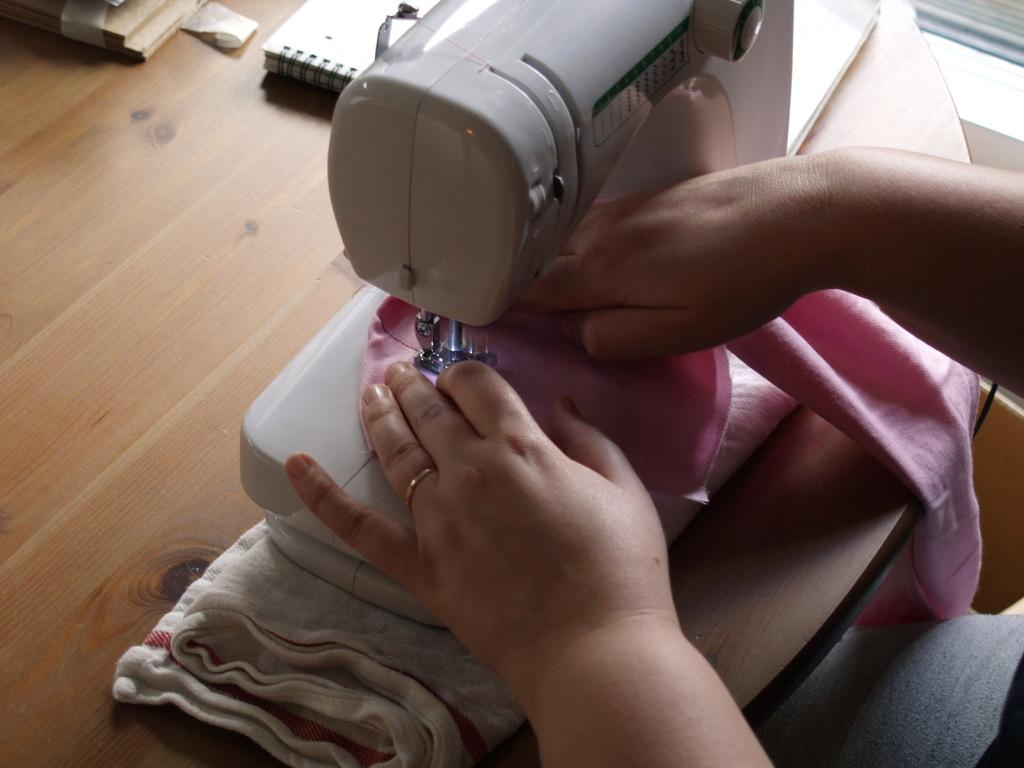What is the main piece of furniture in the image? There is a table in the image. Who or what is on the right side of the image? There is a person on the right side of the image. What items can be seen on the table? There are books, a cloth, and a sewing machine on the table. What part of the person's education is depicted in the image? There is no indication of the person's education in the image. What type of bun is being used to hold the person's hair in the image? There is no person with hair in the image, and therefore no bun can be observed. 